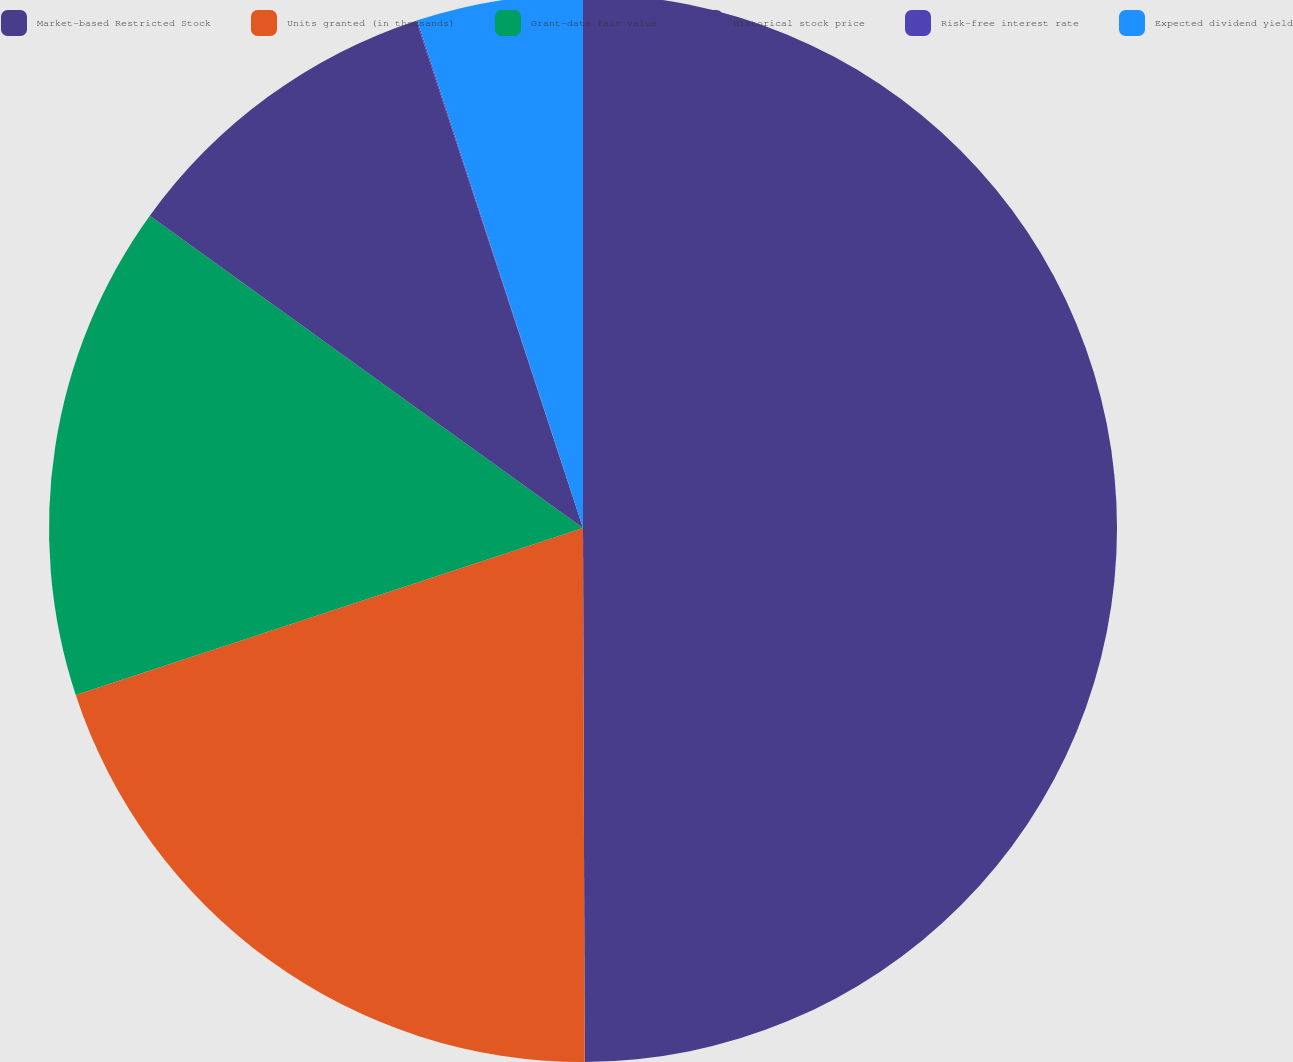<chart> <loc_0><loc_0><loc_500><loc_500><pie_chart><fcel>Market-based Restricted Stock<fcel>Units granted (in thousands)<fcel>Grant-date fair value<fcel>Historical stock price<fcel>Risk-free interest rate<fcel>Expected dividend yield<nl><fcel>49.95%<fcel>19.99%<fcel>15.0%<fcel>10.01%<fcel>0.03%<fcel>5.02%<nl></chart> 